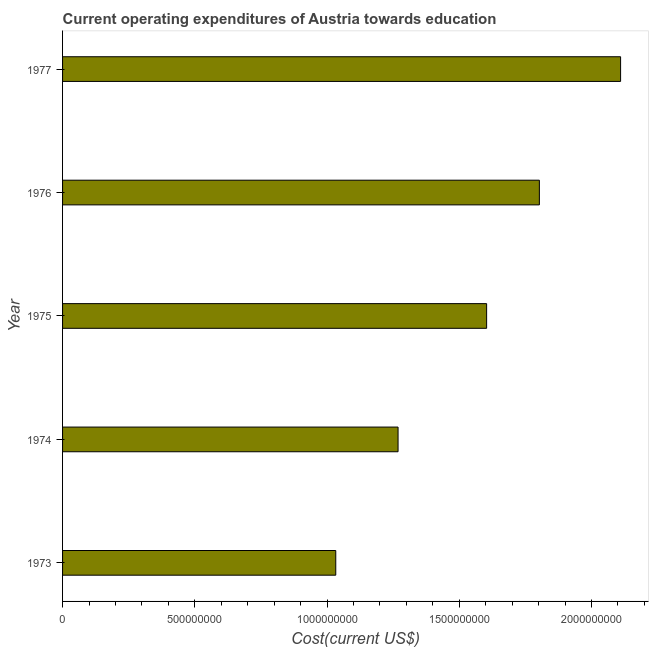What is the title of the graph?
Give a very brief answer. Current operating expenditures of Austria towards education. What is the label or title of the X-axis?
Your answer should be very brief. Cost(current US$). What is the label or title of the Y-axis?
Make the answer very short. Year. What is the education expenditure in 1975?
Your answer should be compact. 1.60e+09. Across all years, what is the maximum education expenditure?
Give a very brief answer. 2.11e+09. Across all years, what is the minimum education expenditure?
Make the answer very short. 1.03e+09. What is the sum of the education expenditure?
Your answer should be very brief. 7.82e+09. What is the difference between the education expenditure in 1975 and 1977?
Keep it short and to the point. -5.07e+08. What is the average education expenditure per year?
Your answer should be compact. 1.56e+09. What is the median education expenditure?
Your answer should be compact. 1.60e+09. What is the ratio of the education expenditure in 1973 to that in 1974?
Offer a very short reply. 0.81. Is the education expenditure in 1974 less than that in 1975?
Offer a terse response. Yes. What is the difference between the highest and the second highest education expenditure?
Your response must be concise. 3.07e+08. Is the sum of the education expenditure in 1973 and 1976 greater than the maximum education expenditure across all years?
Keep it short and to the point. Yes. What is the difference between the highest and the lowest education expenditure?
Provide a succinct answer. 1.08e+09. How many years are there in the graph?
Provide a short and direct response. 5. What is the difference between two consecutive major ticks on the X-axis?
Offer a very short reply. 5.00e+08. What is the Cost(current US$) of 1973?
Your answer should be very brief. 1.03e+09. What is the Cost(current US$) of 1974?
Provide a succinct answer. 1.27e+09. What is the Cost(current US$) of 1975?
Offer a very short reply. 1.60e+09. What is the Cost(current US$) in 1976?
Your answer should be compact. 1.80e+09. What is the Cost(current US$) in 1977?
Your answer should be very brief. 2.11e+09. What is the difference between the Cost(current US$) in 1973 and 1974?
Offer a very short reply. -2.36e+08. What is the difference between the Cost(current US$) in 1973 and 1975?
Ensure brevity in your answer.  -5.70e+08. What is the difference between the Cost(current US$) in 1973 and 1976?
Provide a short and direct response. -7.70e+08. What is the difference between the Cost(current US$) in 1973 and 1977?
Your answer should be very brief. -1.08e+09. What is the difference between the Cost(current US$) in 1974 and 1975?
Offer a terse response. -3.35e+08. What is the difference between the Cost(current US$) in 1974 and 1976?
Ensure brevity in your answer.  -5.34e+08. What is the difference between the Cost(current US$) in 1974 and 1977?
Your response must be concise. -8.41e+08. What is the difference between the Cost(current US$) in 1975 and 1976?
Provide a short and direct response. -1.99e+08. What is the difference between the Cost(current US$) in 1975 and 1977?
Provide a short and direct response. -5.07e+08. What is the difference between the Cost(current US$) in 1976 and 1977?
Your answer should be compact. -3.07e+08. What is the ratio of the Cost(current US$) in 1973 to that in 1974?
Offer a very short reply. 0.81. What is the ratio of the Cost(current US$) in 1973 to that in 1975?
Provide a short and direct response. 0.64. What is the ratio of the Cost(current US$) in 1973 to that in 1976?
Provide a short and direct response. 0.57. What is the ratio of the Cost(current US$) in 1973 to that in 1977?
Your answer should be very brief. 0.49. What is the ratio of the Cost(current US$) in 1974 to that in 1975?
Provide a short and direct response. 0.79. What is the ratio of the Cost(current US$) in 1974 to that in 1976?
Ensure brevity in your answer.  0.7. What is the ratio of the Cost(current US$) in 1974 to that in 1977?
Offer a terse response. 0.6. What is the ratio of the Cost(current US$) in 1975 to that in 1976?
Offer a very short reply. 0.89. What is the ratio of the Cost(current US$) in 1975 to that in 1977?
Provide a succinct answer. 0.76. What is the ratio of the Cost(current US$) in 1976 to that in 1977?
Offer a very short reply. 0.85. 